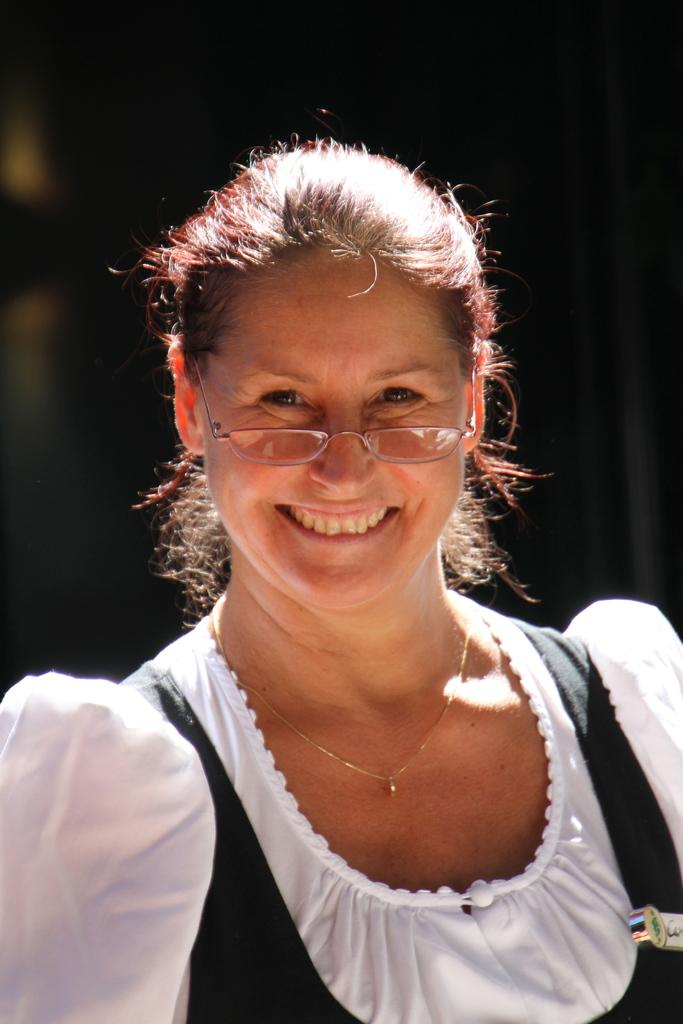Who is the main subject in the image? There is a woman in the image. What is the woman wearing? The woman is wearing a black and white dress. Can you describe the background of the image? The background of the image is blurred. How many toes can be seen on the giraffe in the image? There is no giraffe present in the image, so it is not possible to determine the number of toes. 